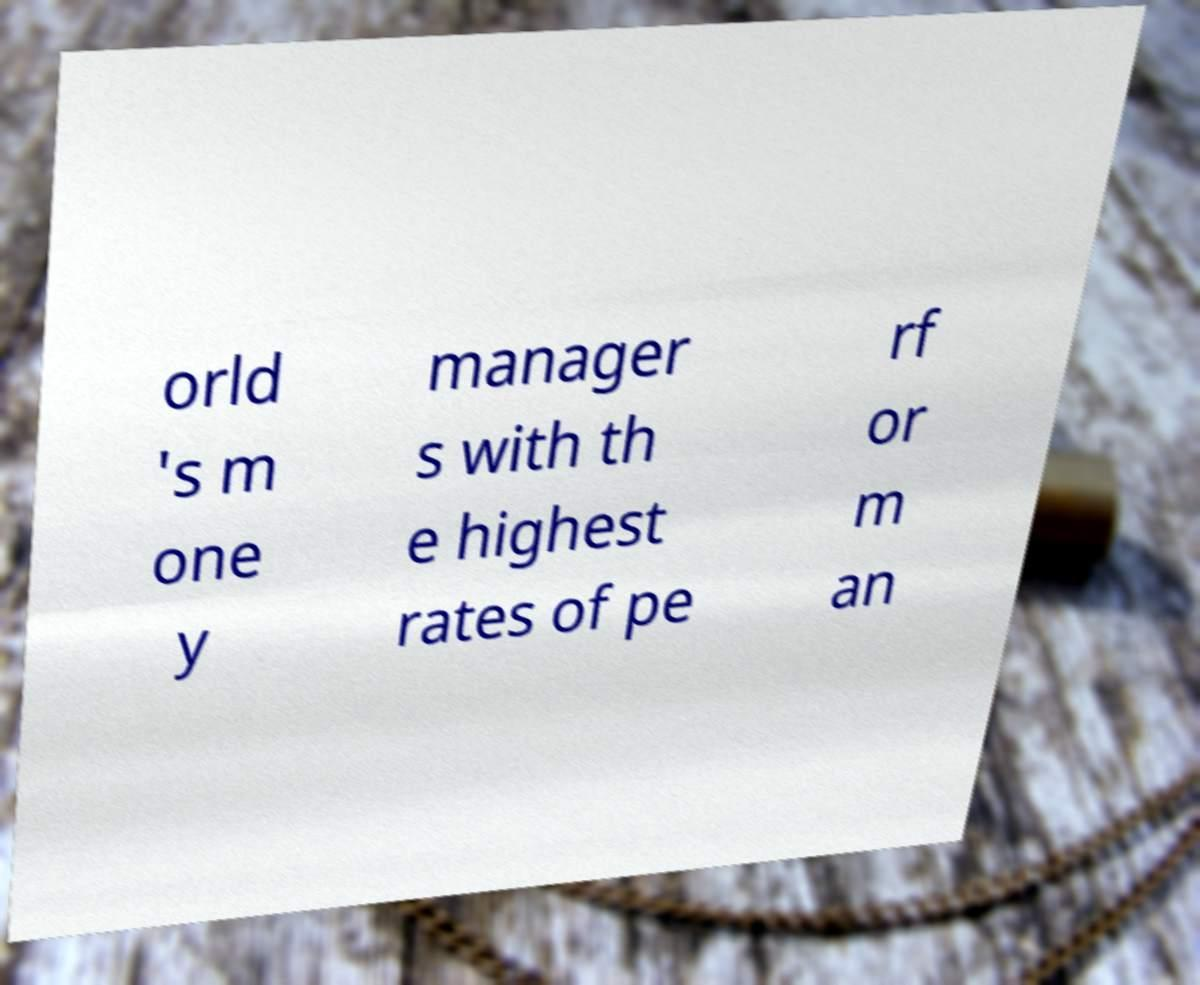I need the written content from this picture converted into text. Can you do that? orld 's m one y manager s with th e highest rates of pe rf or m an 